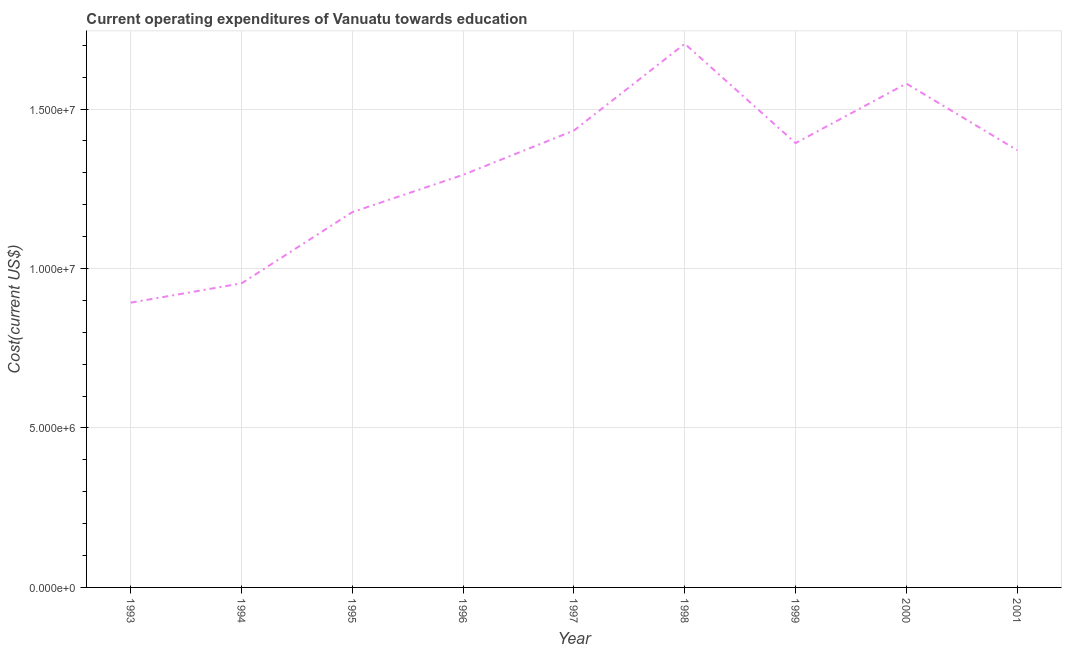What is the education expenditure in 2000?
Make the answer very short. 1.58e+07. Across all years, what is the maximum education expenditure?
Offer a terse response. 1.70e+07. Across all years, what is the minimum education expenditure?
Keep it short and to the point. 8.93e+06. In which year was the education expenditure maximum?
Give a very brief answer. 1998. In which year was the education expenditure minimum?
Your answer should be very brief. 1993. What is the sum of the education expenditure?
Your answer should be compact. 1.18e+08. What is the difference between the education expenditure in 1998 and 2000?
Offer a terse response. 1.25e+06. What is the average education expenditure per year?
Keep it short and to the point. 1.31e+07. What is the median education expenditure?
Offer a terse response. 1.37e+07. In how many years, is the education expenditure greater than 13000000 US$?
Give a very brief answer. 5. What is the ratio of the education expenditure in 1999 to that in 2000?
Your response must be concise. 0.88. Is the difference between the education expenditure in 1997 and 2000 greater than the difference between any two years?
Keep it short and to the point. No. What is the difference between the highest and the second highest education expenditure?
Ensure brevity in your answer.  1.25e+06. What is the difference between the highest and the lowest education expenditure?
Make the answer very short. 8.12e+06. In how many years, is the education expenditure greater than the average education expenditure taken over all years?
Provide a succinct answer. 5. Does the education expenditure monotonically increase over the years?
Provide a short and direct response. No. How many lines are there?
Make the answer very short. 1. Are the values on the major ticks of Y-axis written in scientific E-notation?
Offer a very short reply. Yes. Does the graph contain grids?
Provide a succinct answer. Yes. What is the title of the graph?
Provide a short and direct response. Current operating expenditures of Vanuatu towards education. What is the label or title of the X-axis?
Your answer should be compact. Year. What is the label or title of the Y-axis?
Give a very brief answer. Cost(current US$). What is the Cost(current US$) of 1993?
Make the answer very short. 8.93e+06. What is the Cost(current US$) of 1994?
Provide a short and direct response. 9.54e+06. What is the Cost(current US$) in 1995?
Make the answer very short. 1.18e+07. What is the Cost(current US$) of 1996?
Your response must be concise. 1.29e+07. What is the Cost(current US$) of 1997?
Provide a short and direct response. 1.43e+07. What is the Cost(current US$) of 1998?
Ensure brevity in your answer.  1.70e+07. What is the Cost(current US$) of 1999?
Your answer should be very brief. 1.39e+07. What is the Cost(current US$) of 2000?
Offer a very short reply. 1.58e+07. What is the Cost(current US$) of 2001?
Your response must be concise. 1.37e+07. What is the difference between the Cost(current US$) in 1993 and 1994?
Your answer should be very brief. -6.06e+05. What is the difference between the Cost(current US$) in 1993 and 1995?
Keep it short and to the point. -2.84e+06. What is the difference between the Cost(current US$) in 1993 and 1996?
Provide a succinct answer. -4.01e+06. What is the difference between the Cost(current US$) in 1993 and 1997?
Your answer should be very brief. -5.40e+06. What is the difference between the Cost(current US$) in 1993 and 1998?
Provide a succinct answer. -8.12e+06. What is the difference between the Cost(current US$) in 1993 and 1999?
Provide a succinct answer. -5.00e+06. What is the difference between the Cost(current US$) in 1993 and 2000?
Offer a very short reply. -6.87e+06. What is the difference between the Cost(current US$) in 1993 and 2001?
Keep it short and to the point. -4.78e+06. What is the difference between the Cost(current US$) in 1994 and 1995?
Give a very brief answer. -2.23e+06. What is the difference between the Cost(current US$) in 1994 and 1996?
Provide a short and direct response. -3.40e+06. What is the difference between the Cost(current US$) in 1994 and 1997?
Your response must be concise. -4.79e+06. What is the difference between the Cost(current US$) in 1994 and 1998?
Provide a short and direct response. -7.51e+06. What is the difference between the Cost(current US$) in 1994 and 1999?
Make the answer very short. -4.40e+06. What is the difference between the Cost(current US$) in 1994 and 2000?
Make the answer very short. -6.26e+06. What is the difference between the Cost(current US$) in 1994 and 2001?
Ensure brevity in your answer.  -4.18e+06. What is the difference between the Cost(current US$) in 1995 and 1996?
Give a very brief answer. -1.17e+06. What is the difference between the Cost(current US$) in 1995 and 1997?
Provide a succinct answer. -2.56e+06. What is the difference between the Cost(current US$) in 1995 and 1998?
Make the answer very short. -5.28e+06. What is the difference between the Cost(current US$) in 1995 and 1999?
Offer a very short reply. -2.16e+06. What is the difference between the Cost(current US$) in 1995 and 2000?
Provide a succinct answer. -4.03e+06. What is the difference between the Cost(current US$) in 1995 and 2001?
Make the answer very short. -1.94e+06. What is the difference between the Cost(current US$) in 1996 and 1997?
Provide a short and direct response. -1.39e+06. What is the difference between the Cost(current US$) in 1996 and 1998?
Your answer should be compact. -4.11e+06. What is the difference between the Cost(current US$) in 1996 and 1999?
Provide a succinct answer. -9.95e+05. What is the difference between the Cost(current US$) in 1996 and 2000?
Make the answer very short. -2.86e+06. What is the difference between the Cost(current US$) in 1996 and 2001?
Provide a succinct answer. -7.73e+05. What is the difference between the Cost(current US$) in 1997 and 1998?
Offer a terse response. -2.72e+06. What is the difference between the Cost(current US$) in 1997 and 1999?
Keep it short and to the point. 3.95e+05. What is the difference between the Cost(current US$) in 1997 and 2000?
Make the answer very short. -1.47e+06. What is the difference between the Cost(current US$) in 1997 and 2001?
Ensure brevity in your answer.  6.16e+05. What is the difference between the Cost(current US$) in 1998 and 1999?
Your response must be concise. 3.12e+06. What is the difference between the Cost(current US$) in 1998 and 2000?
Ensure brevity in your answer.  1.25e+06. What is the difference between the Cost(current US$) in 1998 and 2001?
Give a very brief answer. 3.34e+06. What is the difference between the Cost(current US$) in 1999 and 2000?
Provide a short and direct response. -1.87e+06. What is the difference between the Cost(current US$) in 1999 and 2001?
Provide a short and direct response. 2.22e+05. What is the difference between the Cost(current US$) in 2000 and 2001?
Ensure brevity in your answer.  2.09e+06. What is the ratio of the Cost(current US$) in 1993 to that in 1994?
Keep it short and to the point. 0.94. What is the ratio of the Cost(current US$) in 1993 to that in 1995?
Provide a short and direct response. 0.76. What is the ratio of the Cost(current US$) in 1993 to that in 1996?
Give a very brief answer. 0.69. What is the ratio of the Cost(current US$) in 1993 to that in 1997?
Make the answer very short. 0.62. What is the ratio of the Cost(current US$) in 1993 to that in 1998?
Your response must be concise. 0.52. What is the ratio of the Cost(current US$) in 1993 to that in 1999?
Provide a succinct answer. 0.64. What is the ratio of the Cost(current US$) in 1993 to that in 2000?
Give a very brief answer. 0.56. What is the ratio of the Cost(current US$) in 1993 to that in 2001?
Keep it short and to the point. 0.65. What is the ratio of the Cost(current US$) in 1994 to that in 1995?
Your answer should be very brief. 0.81. What is the ratio of the Cost(current US$) in 1994 to that in 1996?
Keep it short and to the point. 0.74. What is the ratio of the Cost(current US$) in 1994 to that in 1997?
Give a very brief answer. 0.67. What is the ratio of the Cost(current US$) in 1994 to that in 1998?
Your response must be concise. 0.56. What is the ratio of the Cost(current US$) in 1994 to that in 1999?
Offer a terse response. 0.68. What is the ratio of the Cost(current US$) in 1994 to that in 2000?
Give a very brief answer. 0.6. What is the ratio of the Cost(current US$) in 1994 to that in 2001?
Your answer should be compact. 0.69. What is the ratio of the Cost(current US$) in 1995 to that in 1996?
Offer a very short reply. 0.91. What is the ratio of the Cost(current US$) in 1995 to that in 1997?
Ensure brevity in your answer.  0.82. What is the ratio of the Cost(current US$) in 1995 to that in 1998?
Provide a succinct answer. 0.69. What is the ratio of the Cost(current US$) in 1995 to that in 1999?
Offer a terse response. 0.84. What is the ratio of the Cost(current US$) in 1995 to that in 2000?
Your answer should be compact. 0.74. What is the ratio of the Cost(current US$) in 1995 to that in 2001?
Give a very brief answer. 0.86. What is the ratio of the Cost(current US$) in 1996 to that in 1997?
Your answer should be compact. 0.9. What is the ratio of the Cost(current US$) in 1996 to that in 1998?
Provide a succinct answer. 0.76. What is the ratio of the Cost(current US$) in 1996 to that in 1999?
Ensure brevity in your answer.  0.93. What is the ratio of the Cost(current US$) in 1996 to that in 2000?
Provide a short and direct response. 0.82. What is the ratio of the Cost(current US$) in 1996 to that in 2001?
Provide a succinct answer. 0.94. What is the ratio of the Cost(current US$) in 1997 to that in 1998?
Offer a terse response. 0.84. What is the ratio of the Cost(current US$) in 1997 to that in 1999?
Your answer should be very brief. 1.03. What is the ratio of the Cost(current US$) in 1997 to that in 2000?
Provide a short and direct response. 0.91. What is the ratio of the Cost(current US$) in 1997 to that in 2001?
Make the answer very short. 1.04. What is the ratio of the Cost(current US$) in 1998 to that in 1999?
Keep it short and to the point. 1.22. What is the ratio of the Cost(current US$) in 1998 to that in 2000?
Give a very brief answer. 1.08. What is the ratio of the Cost(current US$) in 1998 to that in 2001?
Offer a very short reply. 1.24. What is the ratio of the Cost(current US$) in 1999 to that in 2000?
Give a very brief answer. 0.88. What is the ratio of the Cost(current US$) in 2000 to that in 2001?
Offer a very short reply. 1.15. 